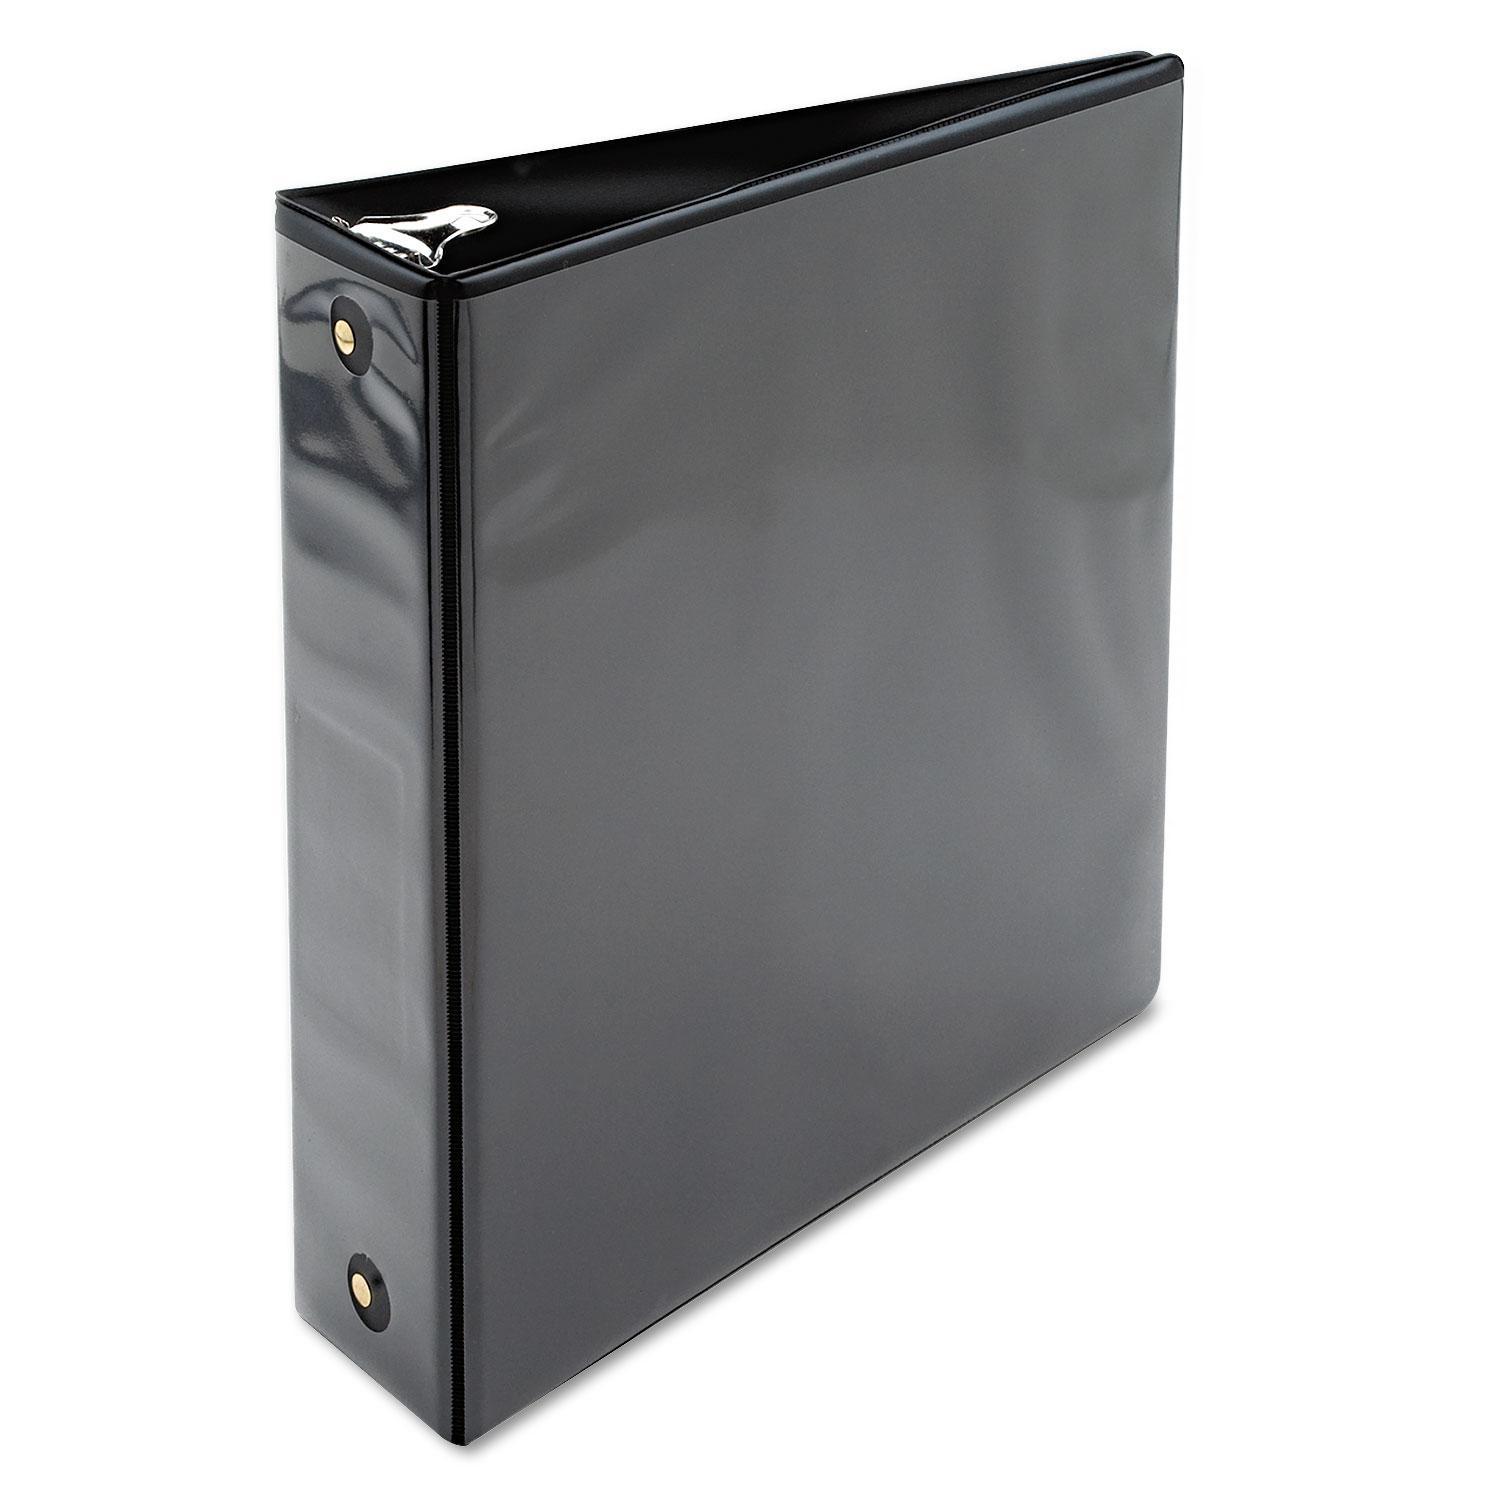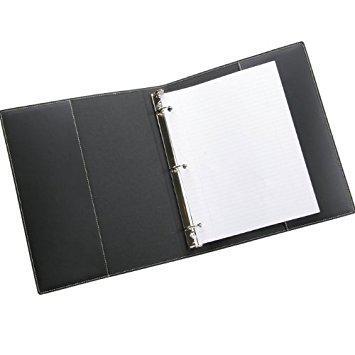The first image is the image on the left, the second image is the image on the right. Considering the images on both sides, is "Both binders are purple." valid? Answer yes or no. No. The first image is the image on the left, the second image is the image on the right. For the images shown, is this caption "Two solid purple binder notebooks are shown in a similar stance, on end with the opening to the back, and have no visible contents." true? Answer yes or no. No. 